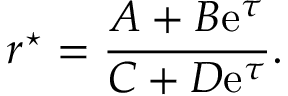Convert formula to latex. <formula><loc_0><loc_0><loc_500><loc_500>r ^ { ^ { * } } = \frac { A + B e ^ { \tau } } { C + D e ^ { \tau } } .</formula> 